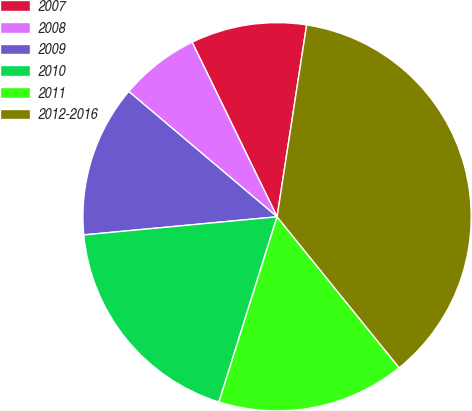<chart> <loc_0><loc_0><loc_500><loc_500><pie_chart><fcel>2007<fcel>2008<fcel>2009<fcel>2010<fcel>2011<fcel>2012-2016<nl><fcel>9.64%<fcel>6.63%<fcel>12.65%<fcel>18.67%<fcel>15.66%<fcel>36.74%<nl></chart> 